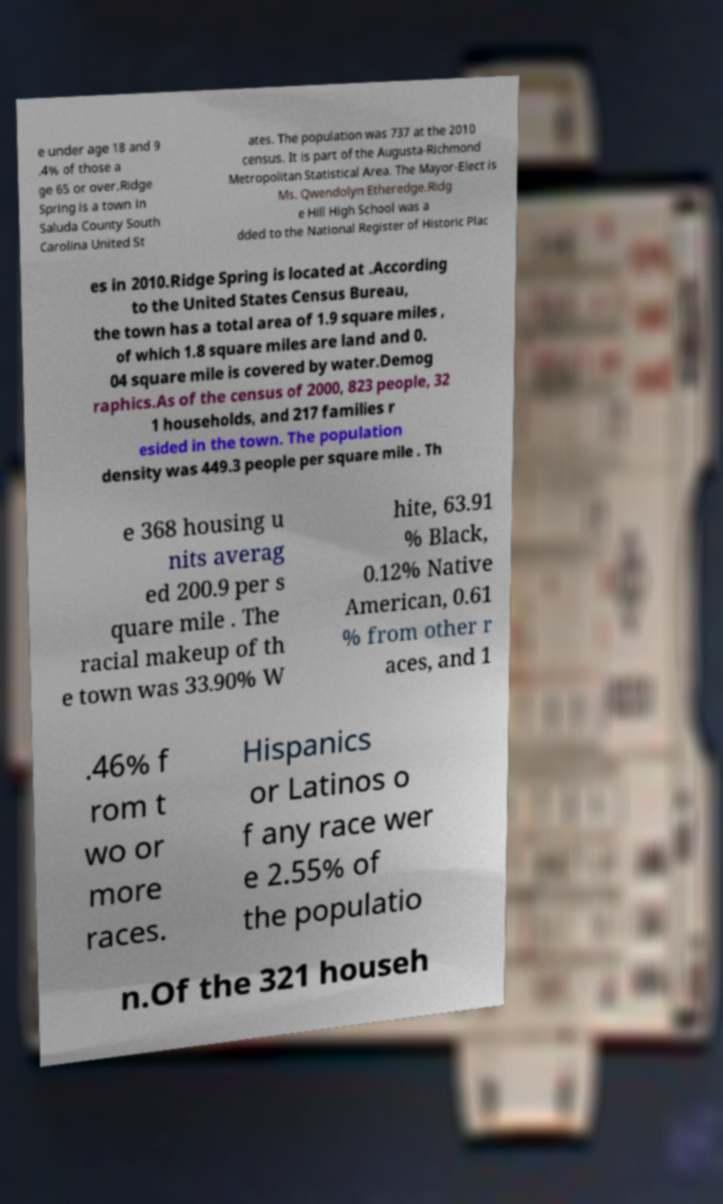I need the written content from this picture converted into text. Can you do that? e under age 18 and 9 .4% of those a ge 65 or over.Ridge Spring is a town in Saluda County South Carolina United St ates. The population was 737 at the 2010 census. It is part of the Augusta-Richmond Metropolitan Statistical Area. The Mayor-Elect is Ms. Qwendolyn Etheredge.Ridg e Hill High School was a dded to the National Register of Historic Plac es in 2010.Ridge Spring is located at .According to the United States Census Bureau, the town has a total area of 1.9 square miles , of which 1.8 square miles are land and 0. 04 square mile is covered by water.Demog raphics.As of the census of 2000, 823 people, 32 1 households, and 217 families r esided in the town. The population density was 449.3 people per square mile . Th e 368 housing u nits averag ed 200.9 per s quare mile . The racial makeup of th e town was 33.90% W hite, 63.91 % Black, 0.12% Native American, 0.61 % from other r aces, and 1 .46% f rom t wo or more races. Hispanics or Latinos o f any race wer e 2.55% of the populatio n.Of the 321 househ 